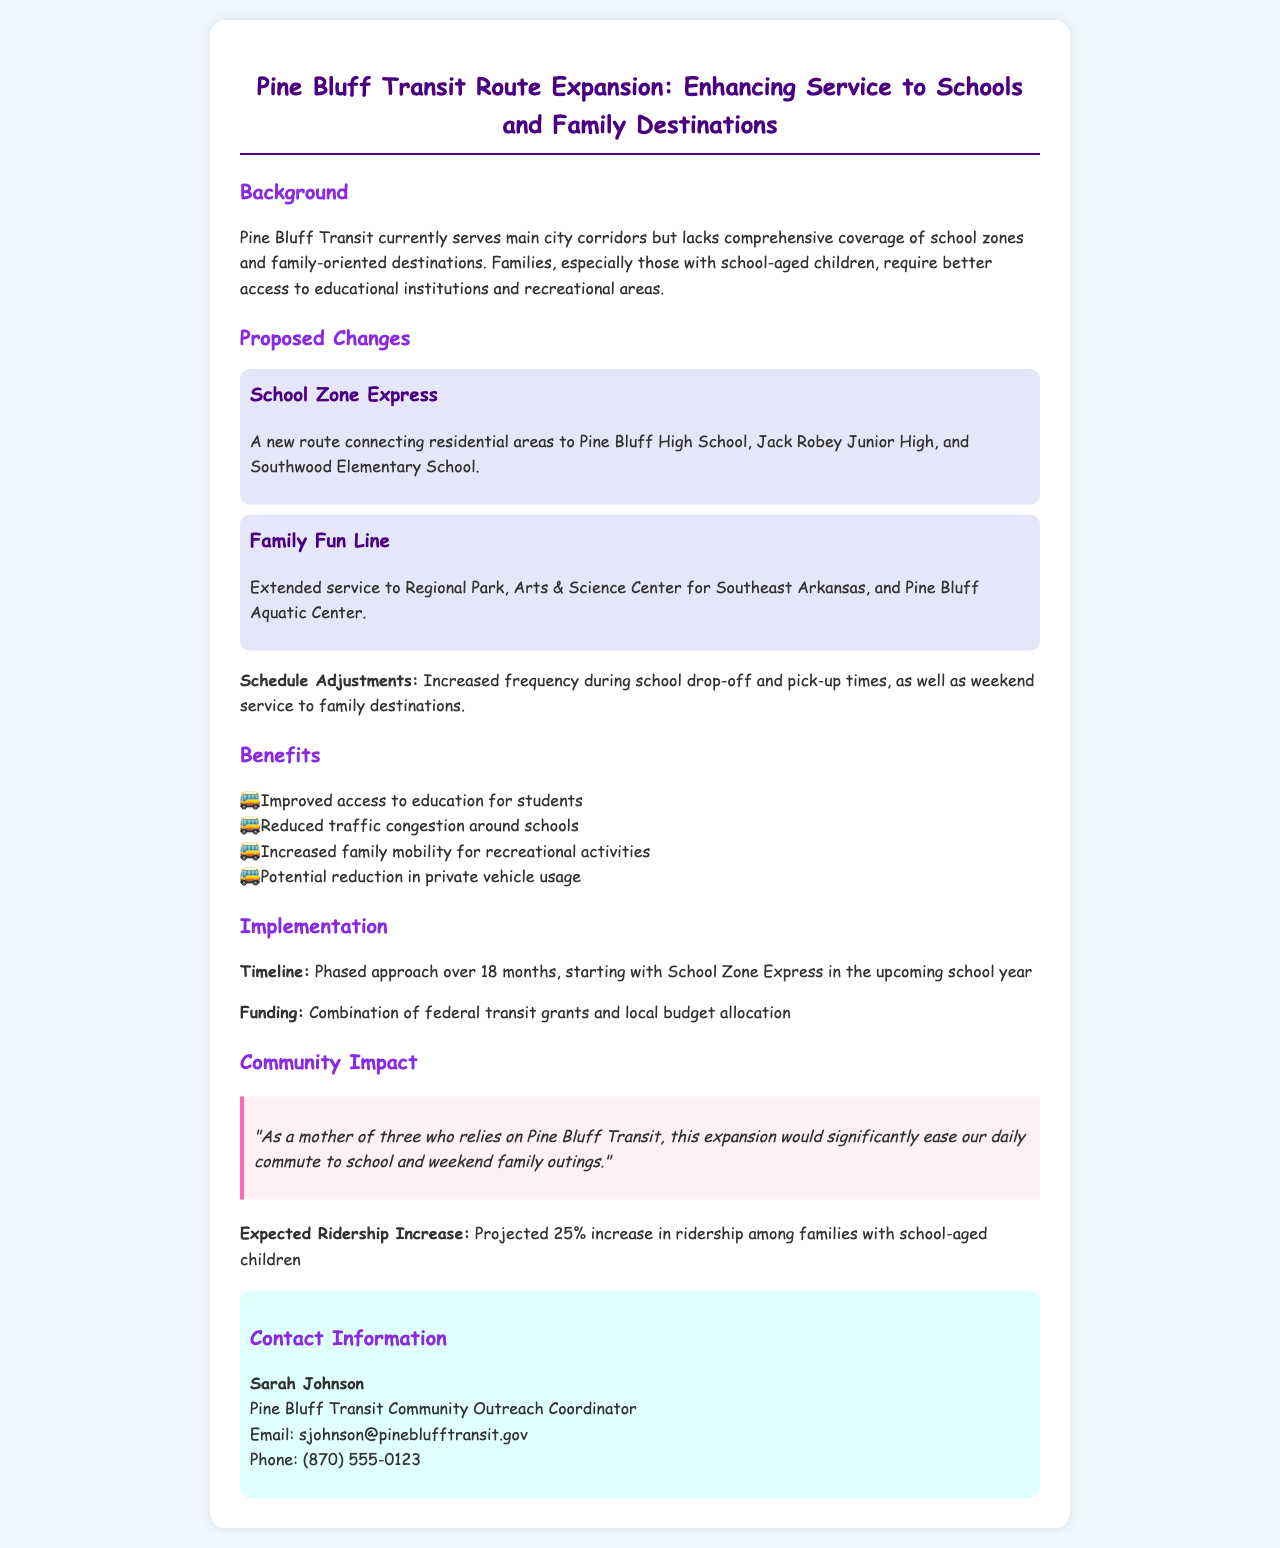What are the names of the schools served by the new route? The document lists Pine Bluff High School, Jack Robey Junior High, and Southwood Elementary School as the schools connected by the new route.
Answer: Pine Bluff High School, Jack Robey Junior High, Southwood Elementary School What is the name of the family-oriented route? The document specifically names the new family-oriented route.
Answer: Family Fun Line What type of funding is used for the expansion? The document mentions the sources of funding for the expansion proposal, specifically details on financing.
Answer: Combination of federal transit grants and local budget allocation What is the projected increase in ridership? The document estimates a specific percentage increase in ridership due to the proposed changes, specifically for families.
Answer: 25% How long will the implementation phase last? The timeline of the implementation phase is clearly outlined in the document, specifically in months.
Answer: 18 months What are the two main benefits of the proposed changes? The document lists several benefits; the question focuses on two specific advantages highlighted within the text.
Answer: Improved access to education, Increased family mobility What specific adjustments are planned for the schedule? The document refers to specific time-based adjustments to improve service during particular times of the day.
Answer: Increased frequency during school drop-off and pick-up times, weekend service Who is the contact person for the proposal? The document provides the contact information for a specific individual related to the transit proposal.
Answer: Sarah Johnson 